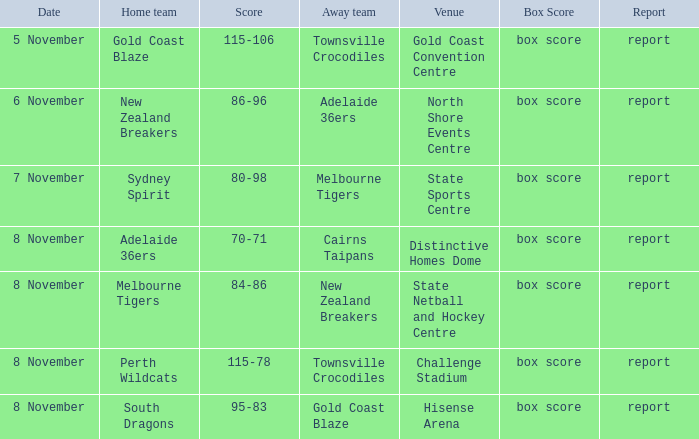What is the specific date of the game where the opponent was gold coast blaze? 8 November. 